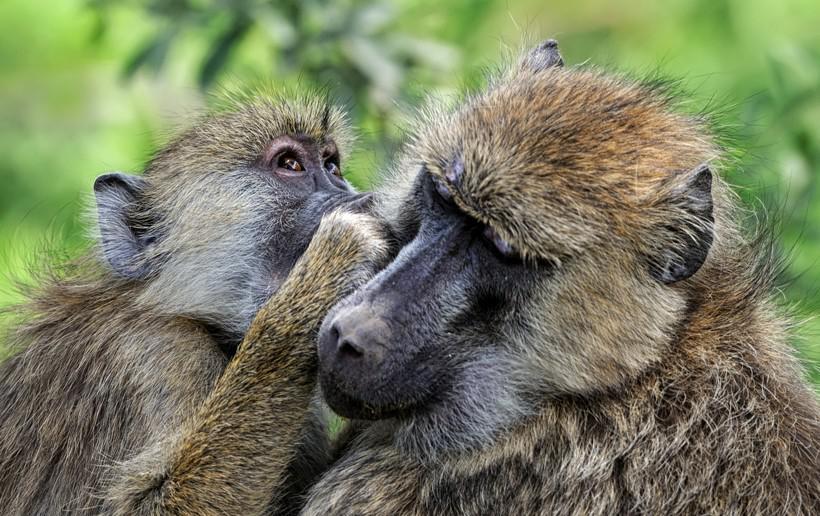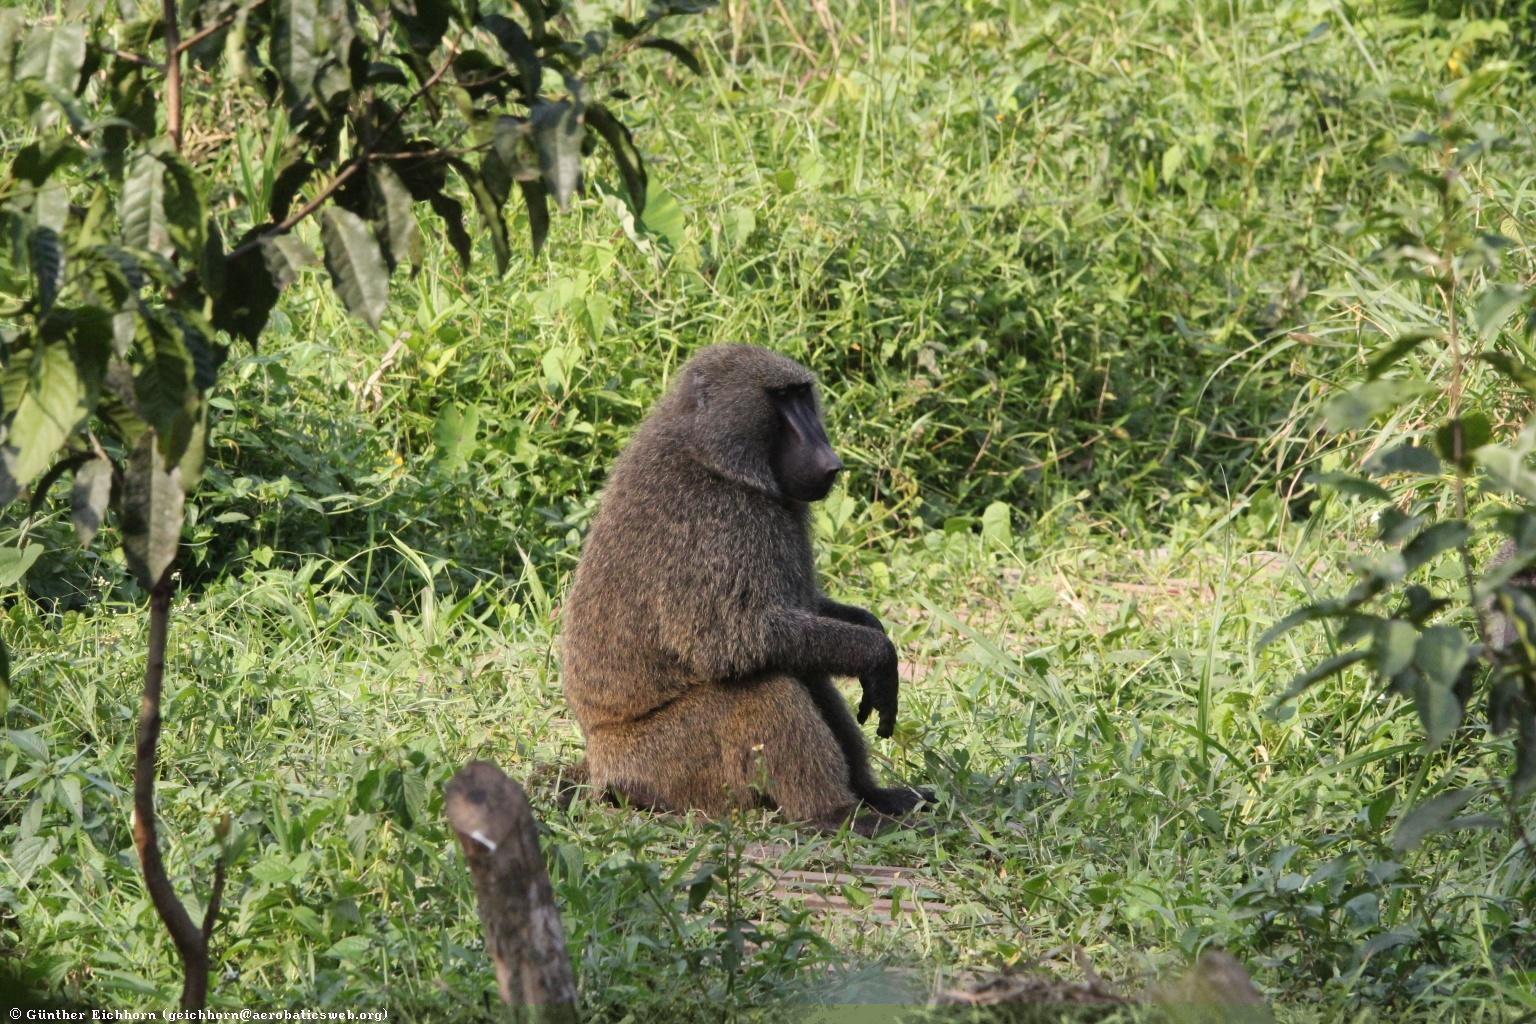The first image is the image on the left, the second image is the image on the right. Analyze the images presented: Is the assertion "Left image shows one baboon, posed amid leafy foliage." valid? Answer yes or no. No. The first image is the image on the left, the second image is the image on the right. Considering the images on both sides, is "The image on the left shows a single chimp in the leaves of a tree." valid? Answer yes or no. No. 